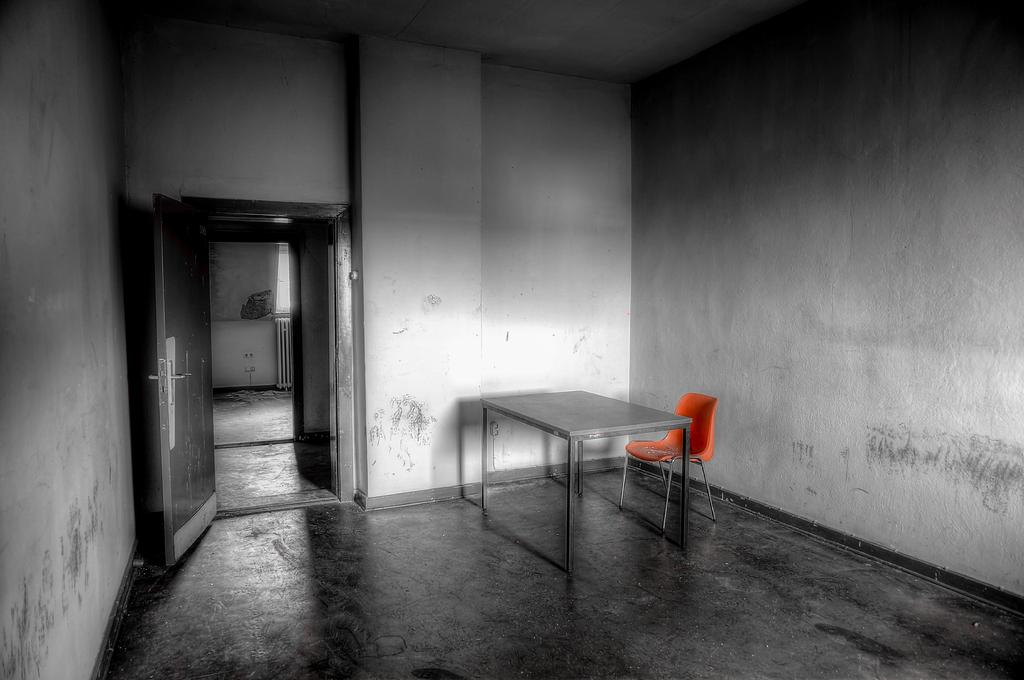What type of furniture is present in the image? There is a table in the image. Are there any other furniture pieces visible in the image? Yes, there are chairs in the image. What type of architectural elements can be seen in the image? There are walls in the image. What type of surface is present under the furniture? There is a floor in the image. How can one access other rooms from the location depicted in the image? There is a door in the image that provides access to other rooms. What type of brick is being used to build the cat in the image? There is no cat or brick present in the image. 